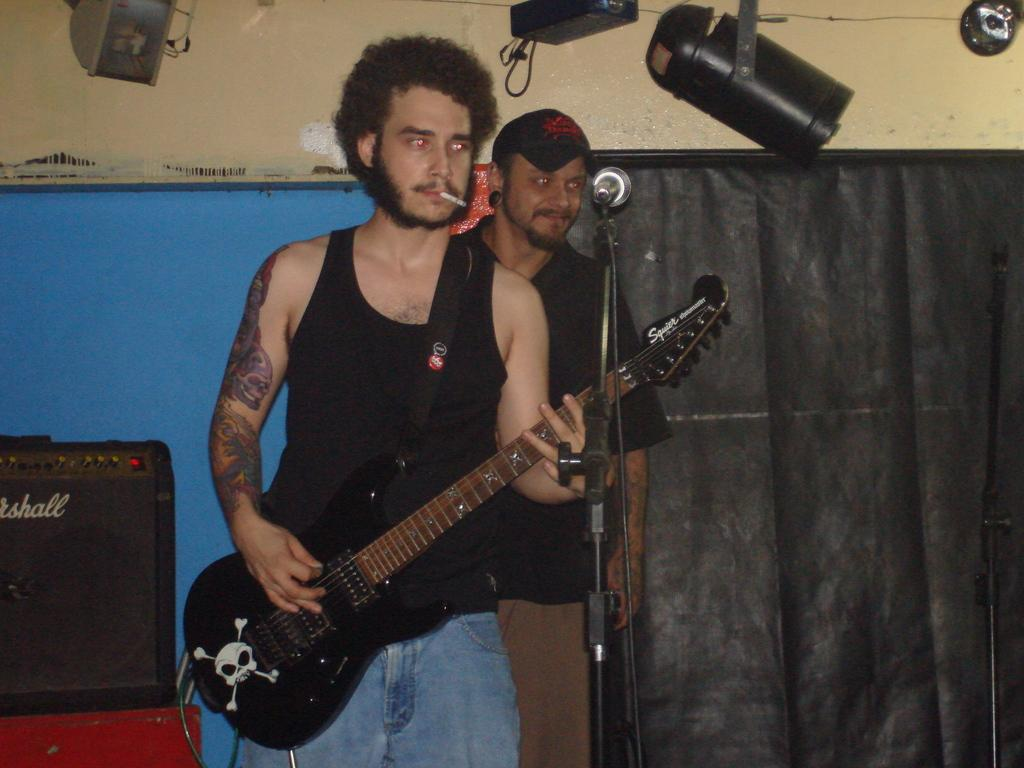What is the man in the image holding? The man is holding a guitar in the image. What is the man doing with the guitar? The man is playing the guitar in the image. What is the man doing besides playing the guitar? The man is smoking in the image. Can you describe the second man in the image? The second man is in the image, and he is smiling. Where is the calendar located in the image? There is no calendar present in the image. What type of dolls can be seen on the shelf in the image? There is no shelf or dolls present in the image. 